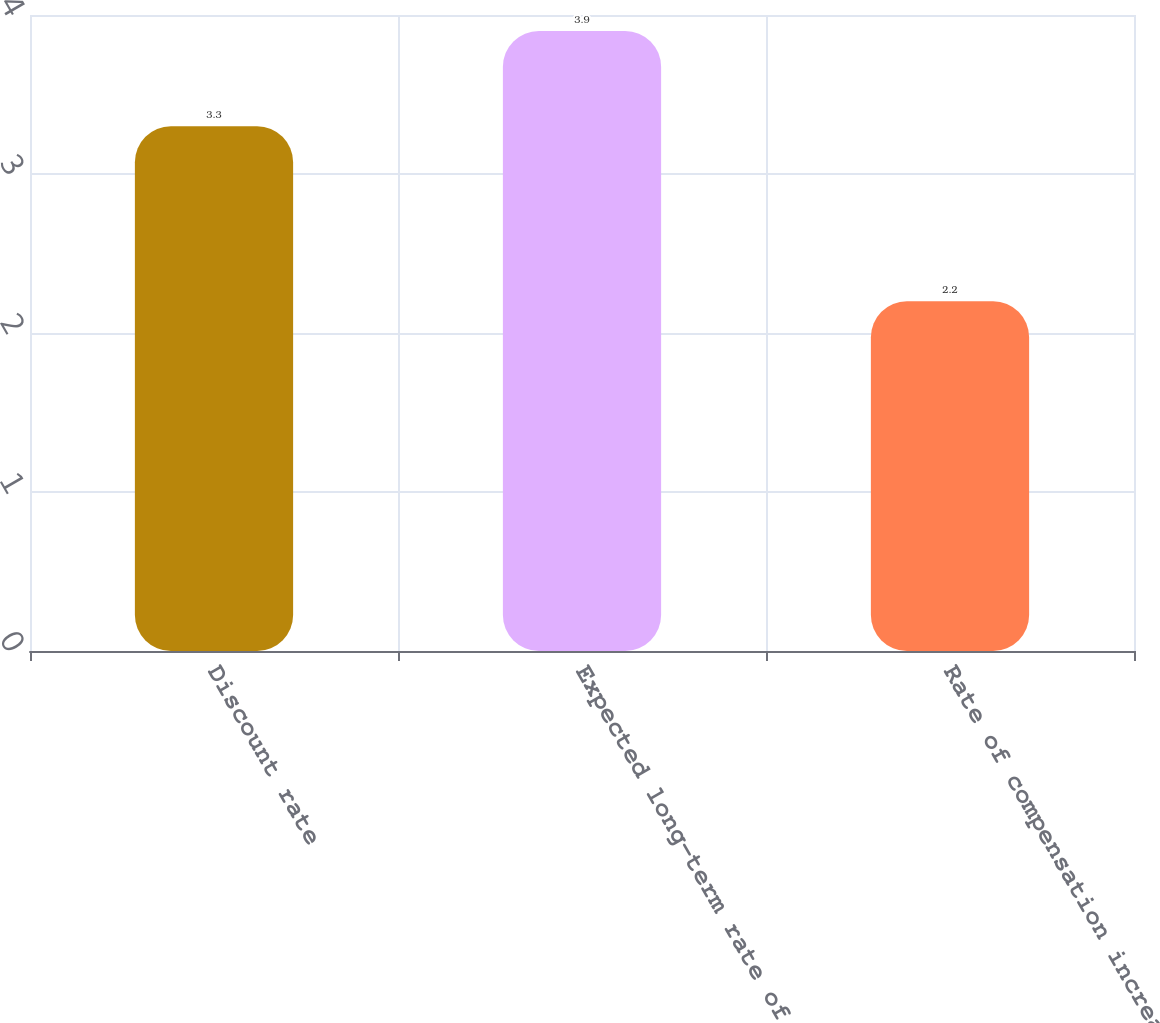Convert chart. <chart><loc_0><loc_0><loc_500><loc_500><bar_chart><fcel>Discount rate<fcel>Expected long-term rate of<fcel>Rate of compensation increase<nl><fcel>3.3<fcel>3.9<fcel>2.2<nl></chart> 